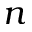Convert formula to latex. <formula><loc_0><loc_0><loc_500><loc_500>n</formula> 